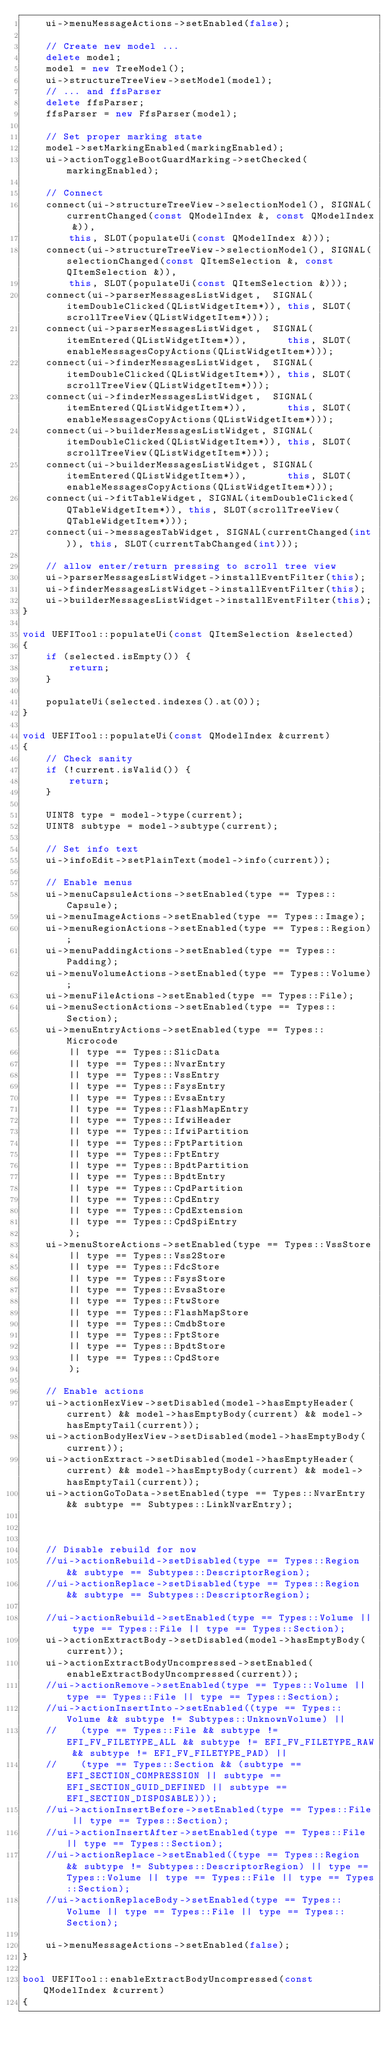<code> <loc_0><loc_0><loc_500><loc_500><_C++_>    ui->menuMessageActions->setEnabled(false);

    // Create new model ...
    delete model;
    model = new TreeModel();
    ui->structureTreeView->setModel(model);
    // ... and ffsParser
    delete ffsParser;
    ffsParser = new FfsParser(model);

    // Set proper marking state
    model->setMarkingEnabled(markingEnabled);
    ui->actionToggleBootGuardMarking->setChecked(markingEnabled);

    // Connect
    connect(ui->structureTreeView->selectionModel(), SIGNAL(currentChanged(const QModelIndex &, const QModelIndex &)),
        this, SLOT(populateUi(const QModelIndex &)));
    connect(ui->structureTreeView->selectionModel(), SIGNAL(selectionChanged(const QItemSelection &, const QItemSelection &)),
        this, SLOT(populateUi(const QItemSelection &)));
    connect(ui->parserMessagesListWidget,  SIGNAL(itemDoubleClicked(QListWidgetItem*)), this, SLOT(scrollTreeView(QListWidgetItem*)));
    connect(ui->parserMessagesListWidget,  SIGNAL(itemEntered(QListWidgetItem*)),       this, SLOT(enableMessagesCopyActions(QListWidgetItem*)));
    connect(ui->finderMessagesListWidget,  SIGNAL(itemDoubleClicked(QListWidgetItem*)), this, SLOT(scrollTreeView(QListWidgetItem*)));
    connect(ui->finderMessagesListWidget,  SIGNAL(itemEntered(QListWidgetItem*)),       this, SLOT(enableMessagesCopyActions(QListWidgetItem*)));
    connect(ui->builderMessagesListWidget, SIGNAL(itemDoubleClicked(QListWidgetItem*)), this, SLOT(scrollTreeView(QListWidgetItem*)));
    connect(ui->builderMessagesListWidget, SIGNAL(itemEntered(QListWidgetItem*)),       this, SLOT(enableMessagesCopyActions(QListWidgetItem*)));
    connect(ui->fitTableWidget, SIGNAL(itemDoubleClicked(QTableWidgetItem*)), this, SLOT(scrollTreeView(QTableWidgetItem*)));
    connect(ui->messagesTabWidget, SIGNAL(currentChanged(int)), this, SLOT(currentTabChanged(int)));

    // allow enter/return pressing to scroll tree view
    ui->parserMessagesListWidget->installEventFilter(this);
    ui->finderMessagesListWidget->installEventFilter(this);
    ui->builderMessagesListWidget->installEventFilter(this);
}

void UEFITool::populateUi(const QItemSelection &selected)
{
    if (selected.isEmpty()) {
        return;
    }

    populateUi(selected.indexes().at(0));
}

void UEFITool::populateUi(const QModelIndex &current)
{
    // Check sanity
    if (!current.isValid()) {
        return;
    }

    UINT8 type = model->type(current);
    UINT8 subtype = model->subtype(current);

    // Set info text
    ui->infoEdit->setPlainText(model->info(current));

    // Enable menus
    ui->menuCapsuleActions->setEnabled(type == Types::Capsule);
    ui->menuImageActions->setEnabled(type == Types::Image);
    ui->menuRegionActions->setEnabled(type == Types::Region);
    ui->menuPaddingActions->setEnabled(type == Types::Padding);
    ui->menuVolumeActions->setEnabled(type == Types::Volume);
    ui->menuFileActions->setEnabled(type == Types::File);
    ui->menuSectionActions->setEnabled(type == Types::Section);
    ui->menuEntryActions->setEnabled(type == Types::Microcode
        || type == Types::SlicData
        || type == Types::NvarEntry
        || type == Types::VssEntry
        || type == Types::FsysEntry
        || type == Types::EvsaEntry
        || type == Types::FlashMapEntry
        || type == Types::IfwiHeader
        || type == Types::IfwiPartition
        || type == Types::FptPartition
        || type == Types::FptEntry
        || type == Types::BpdtPartition
        || type == Types::BpdtEntry
        || type == Types::CpdPartition
        || type == Types::CpdEntry
        || type == Types::CpdExtension
        || type == Types::CpdSpiEntry
        );
    ui->menuStoreActions->setEnabled(type == Types::VssStore
        || type == Types::Vss2Store
        || type == Types::FdcStore
        || type == Types::FsysStore
        || type == Types::EvsaStore
        || type == Types::FtwStore
        || type == Types::FlashMapStore
        || type == Types::CmdbStore
        || type == Types::FptStore
        || type == Types::BpdtStore
        || type == Types::CpdStore
        );

    // Enable actions
    ui->actionHexView->setDisabled(model->hasEmptyHeader(current) && model->hasEmptyBody(current) && model->hasEmptyTail(current));
    ui->actionBodyHexView->setDisabled(model->hasEmptyBody(current));
    ui->actionExtract->setDisabled(model->hasEmptyHeader(current) && model->hasEmptyBody(current) && model->hasEmptyTail(current));
    ui->actionGoToData->setEnabled(type == Types::NvarEntry && subtype == Subtypes::LinkNvarEntry);



    // Disable rebuild for now
    //ui->actionRebuild->setDisabled(type == Types::Region && subtype == Subtypes::DescriptorRegion);
    //ui->actionReplace->setDisabled(type == Types::Region && subtype == Subtypes::DescriptorRegion);

    //ui->actionRebuild->setEnabled(type == Types::Volume || type == Types::File || type == Types::Section);
    ui->actionExtractBody->setDisabled(model->hasEmptyBody(current));
    ui->actionExtractBodyUncompressed->setEnabled(enableExtractBodyUncompressed(current));
    //ui->actionRemove->setEnabled(type == Types::Volume || type == Types::File || type == Types::Section);
    //ui->actionInsertInto->setEnabled((type == Types::Volume && subtype != Subtypes::UnknownVolume) ||
    //    (type == Types::File && subtype != EFI_FV_FILETYPE_ALL && subtype != EFI_FV_FILETYPE_RAW && subtype != EFI_FV_FILETYPE_PAD) ||
    //    (type == Types::Section && (subtype == EFI_SECTION_COMPRESSION || subtype == EFI_SECTION_GUID_DEFINED || subtype == EFI_SECTION_DISPOSABLE)));
    //ui->actionInsertBefore->setEnabled(type == Types::File || type == Types::Section);
    //ui->actionInsertAfter->setEnabled(type == Types::File || type == Types::Section);
    //ui->actionReplace->setEnabled((type == Types::Region && subtype != Subtypes::DescriptorRegion) || type == Types::Volume || type == Types::File || type == Types::Section);
    //ui->actionReplaceBody->setEnabled(type == Types::Volume || type == Types::File || type == Types::Section);

    ui->menuMessageActions->setEnabled(false);
}

bool UEFITool::enableExtractBodyUncompressed(const QModelIndex &current)
{</code> 